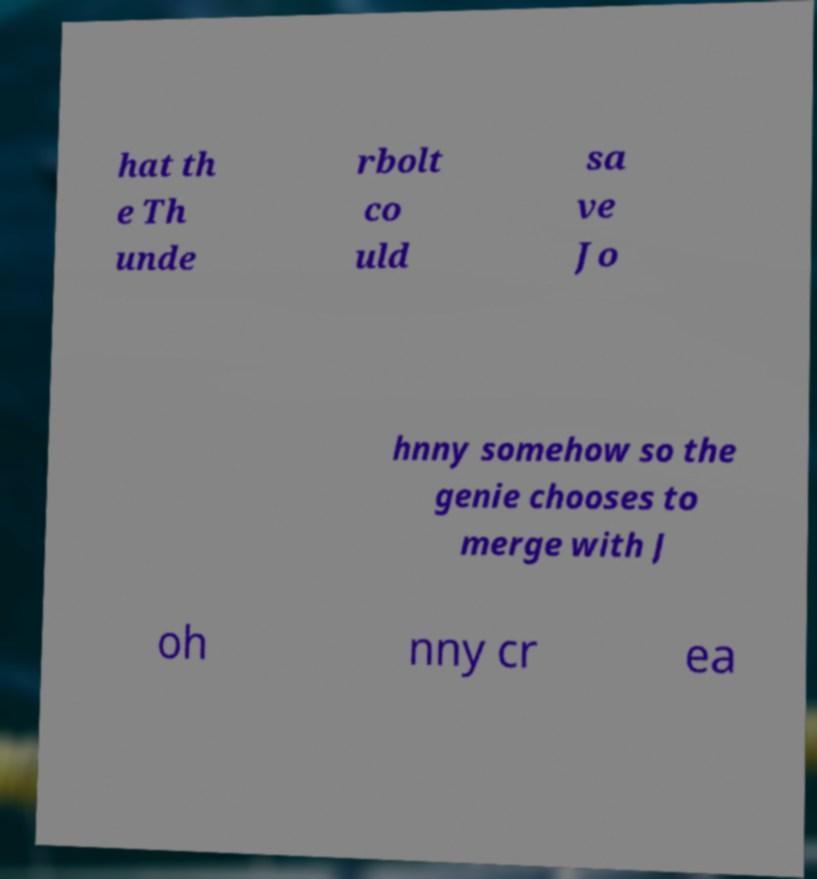I need the written content from this picture converted into text. Can you do that? hat th e Th unde rbolt co uld sa ve Jo hnny somehow so the genie chooses to merge with J oh nny cr ea 